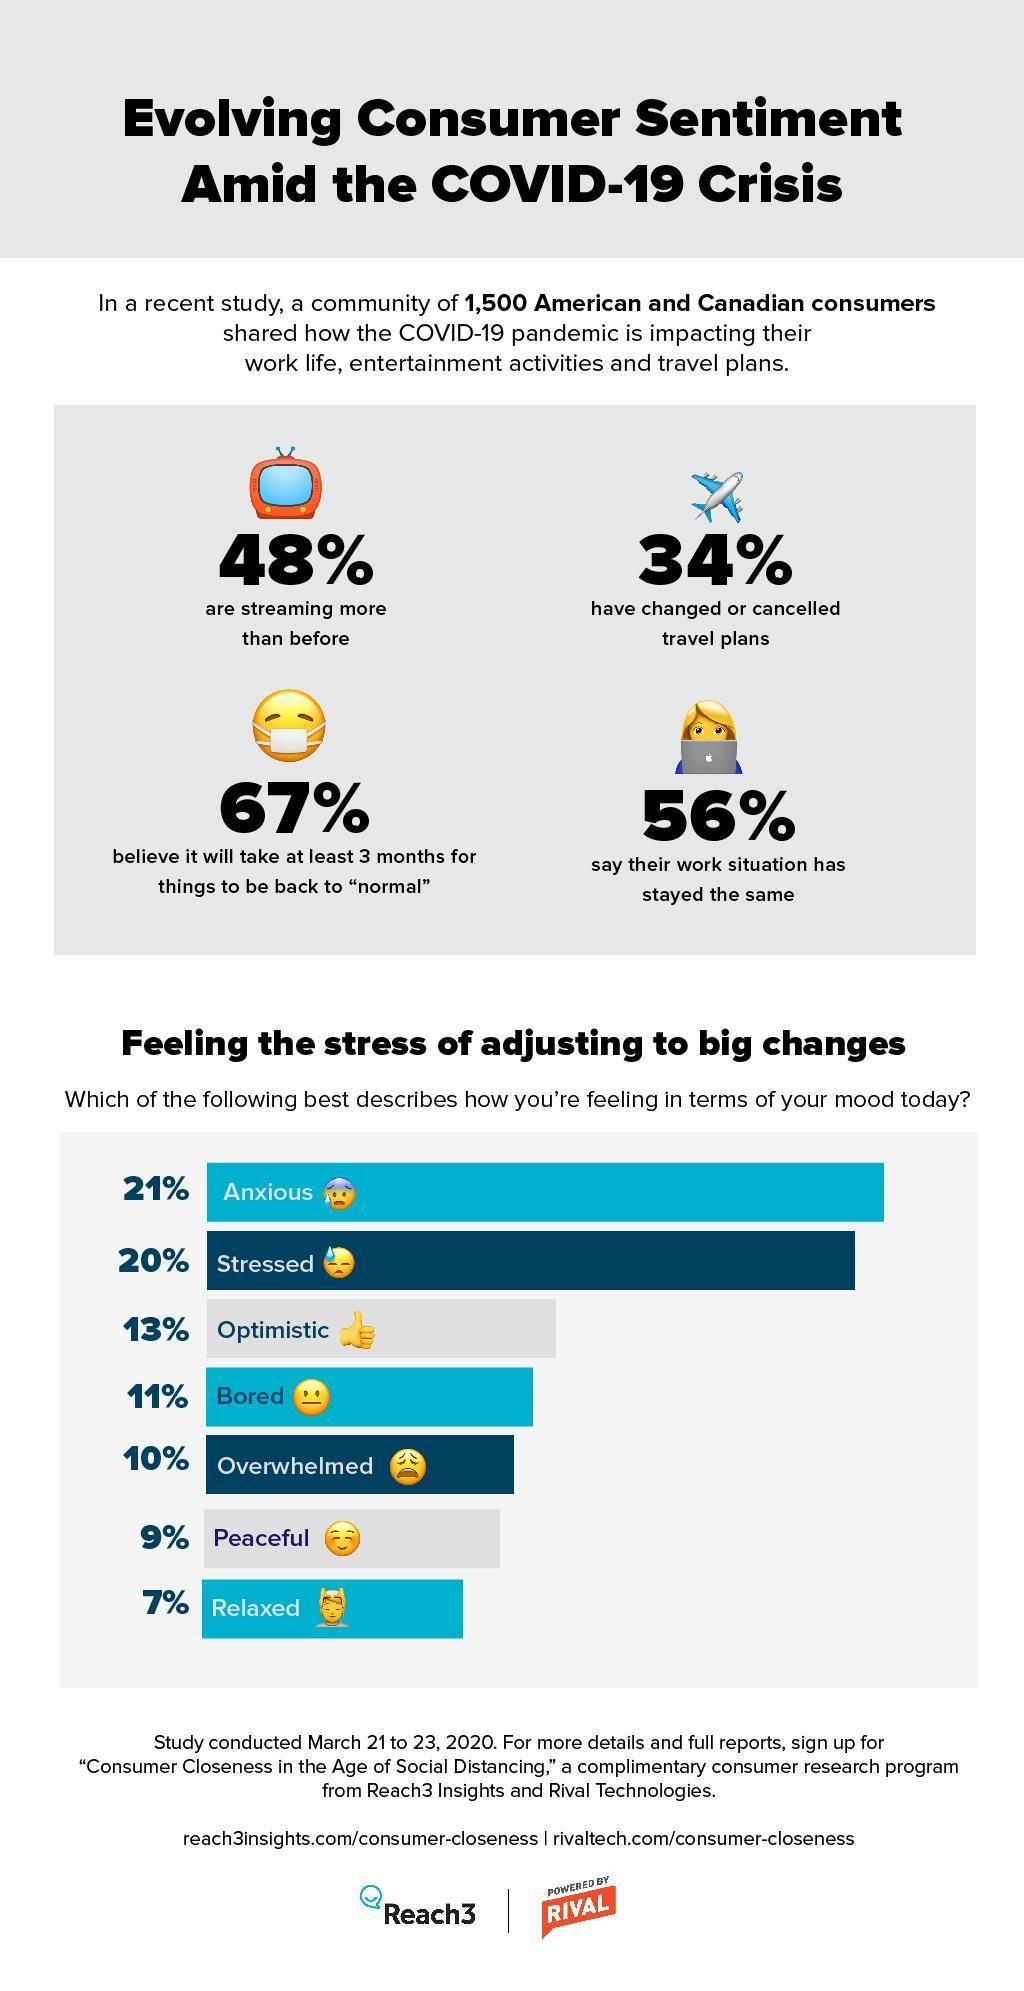How many of the people feel that in 3 months life will return to normal?
Answer the question with a short phrase. 67% What is the combined percent of people feeling peaceful and relaxed? 16% What percent of people have altered their trip plans? 34% For how many of the people has the work situation remained unchanged? 56% 